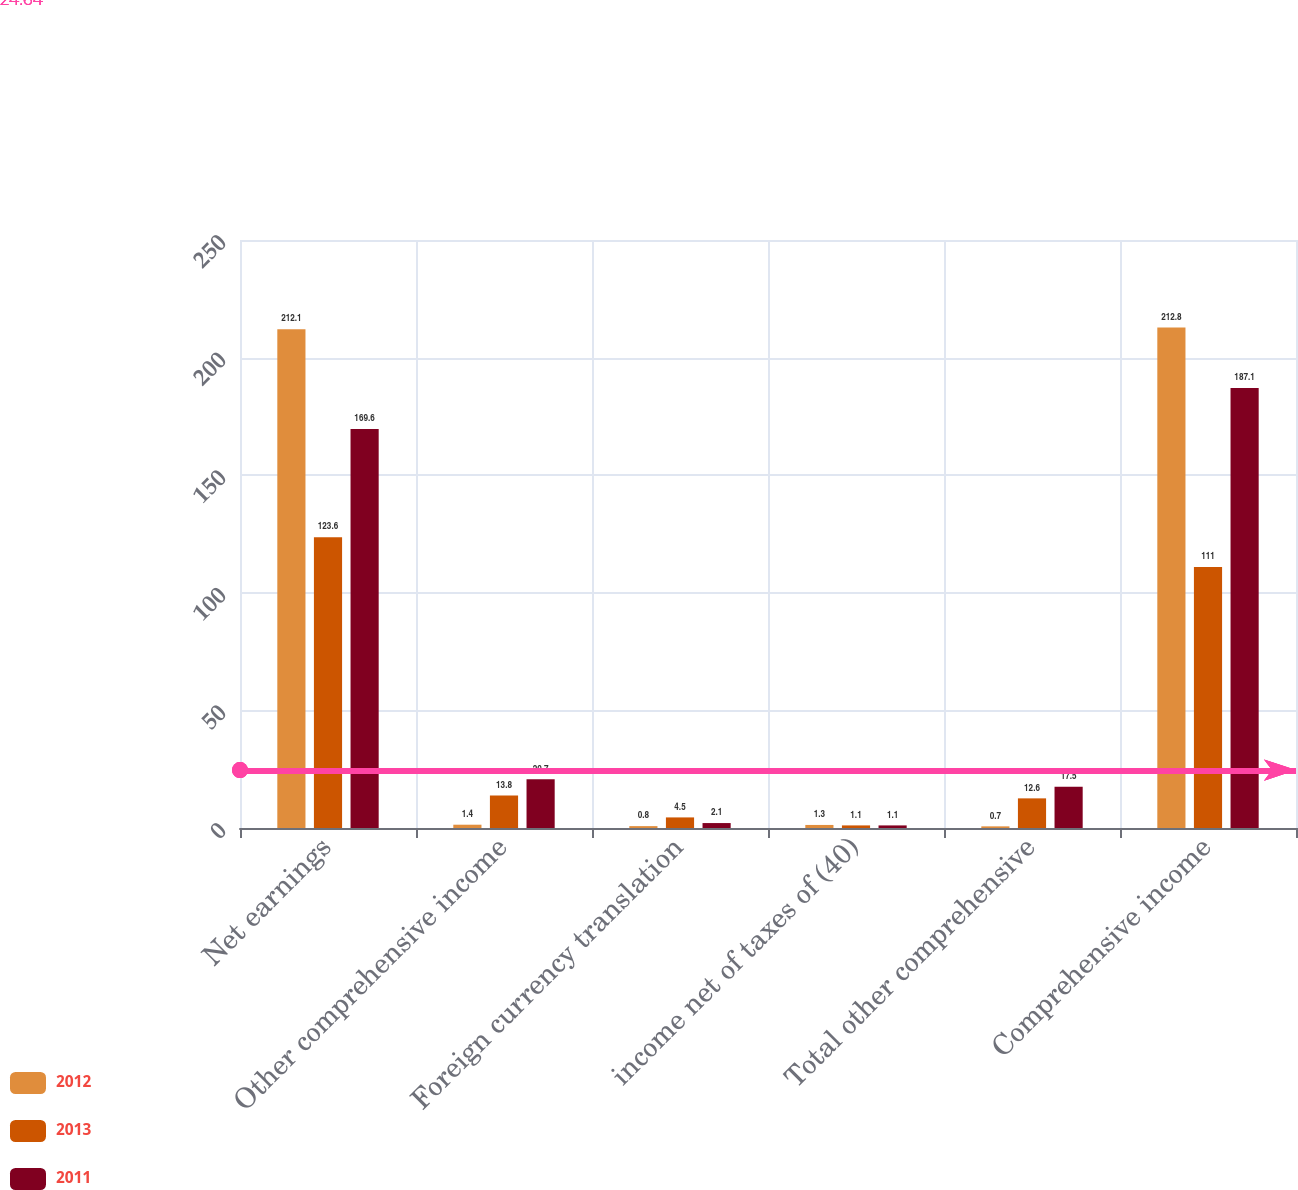Convert chart. <chart><loc_0><loc_0><loc_500><loc_500><stacked_bar_chart><ecel><fcel>Net earnings<fcel>Other comprehensive income<fcel>Foreign currency translation<fcel>income net of taxes of (40)<fcel>Total other comprehensive<fcel>Comprehensive income<nl><fcel>2012<fcel>212.1<fcel>1.4<fcel>0.8<fcel>1.3<fcel>0.7<fcel>212.8<nl><fcel>2013<fcel>123.6<fcel>13.8<fcel>4.5<fcel>1.1<fcel>12.6<fcel>111<nl><fcel>2011<fcel>169.6<fcel>20.7<fcel>2.1<fcel>1.1<fcel>17.5<fcel>187.1<nl></chart> 